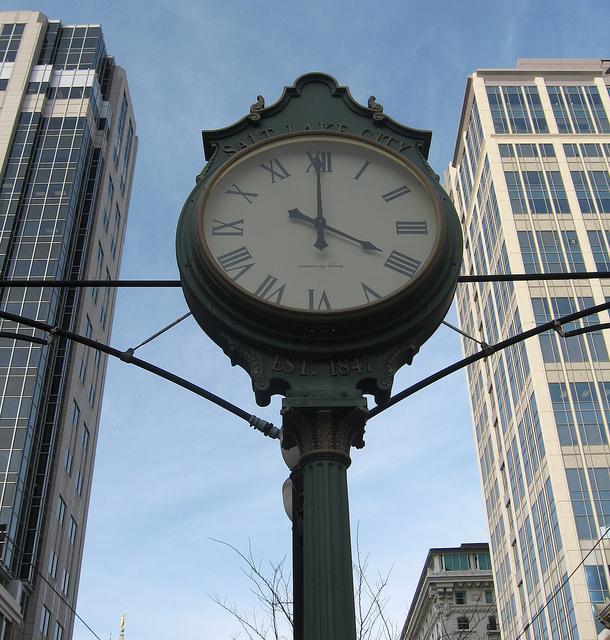How many horses are there?
Give a very brief answer. 0. 